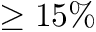<formula> <loc_0><loc_0><loc_500><loc_500>\geq 1 5 \%</formula> 